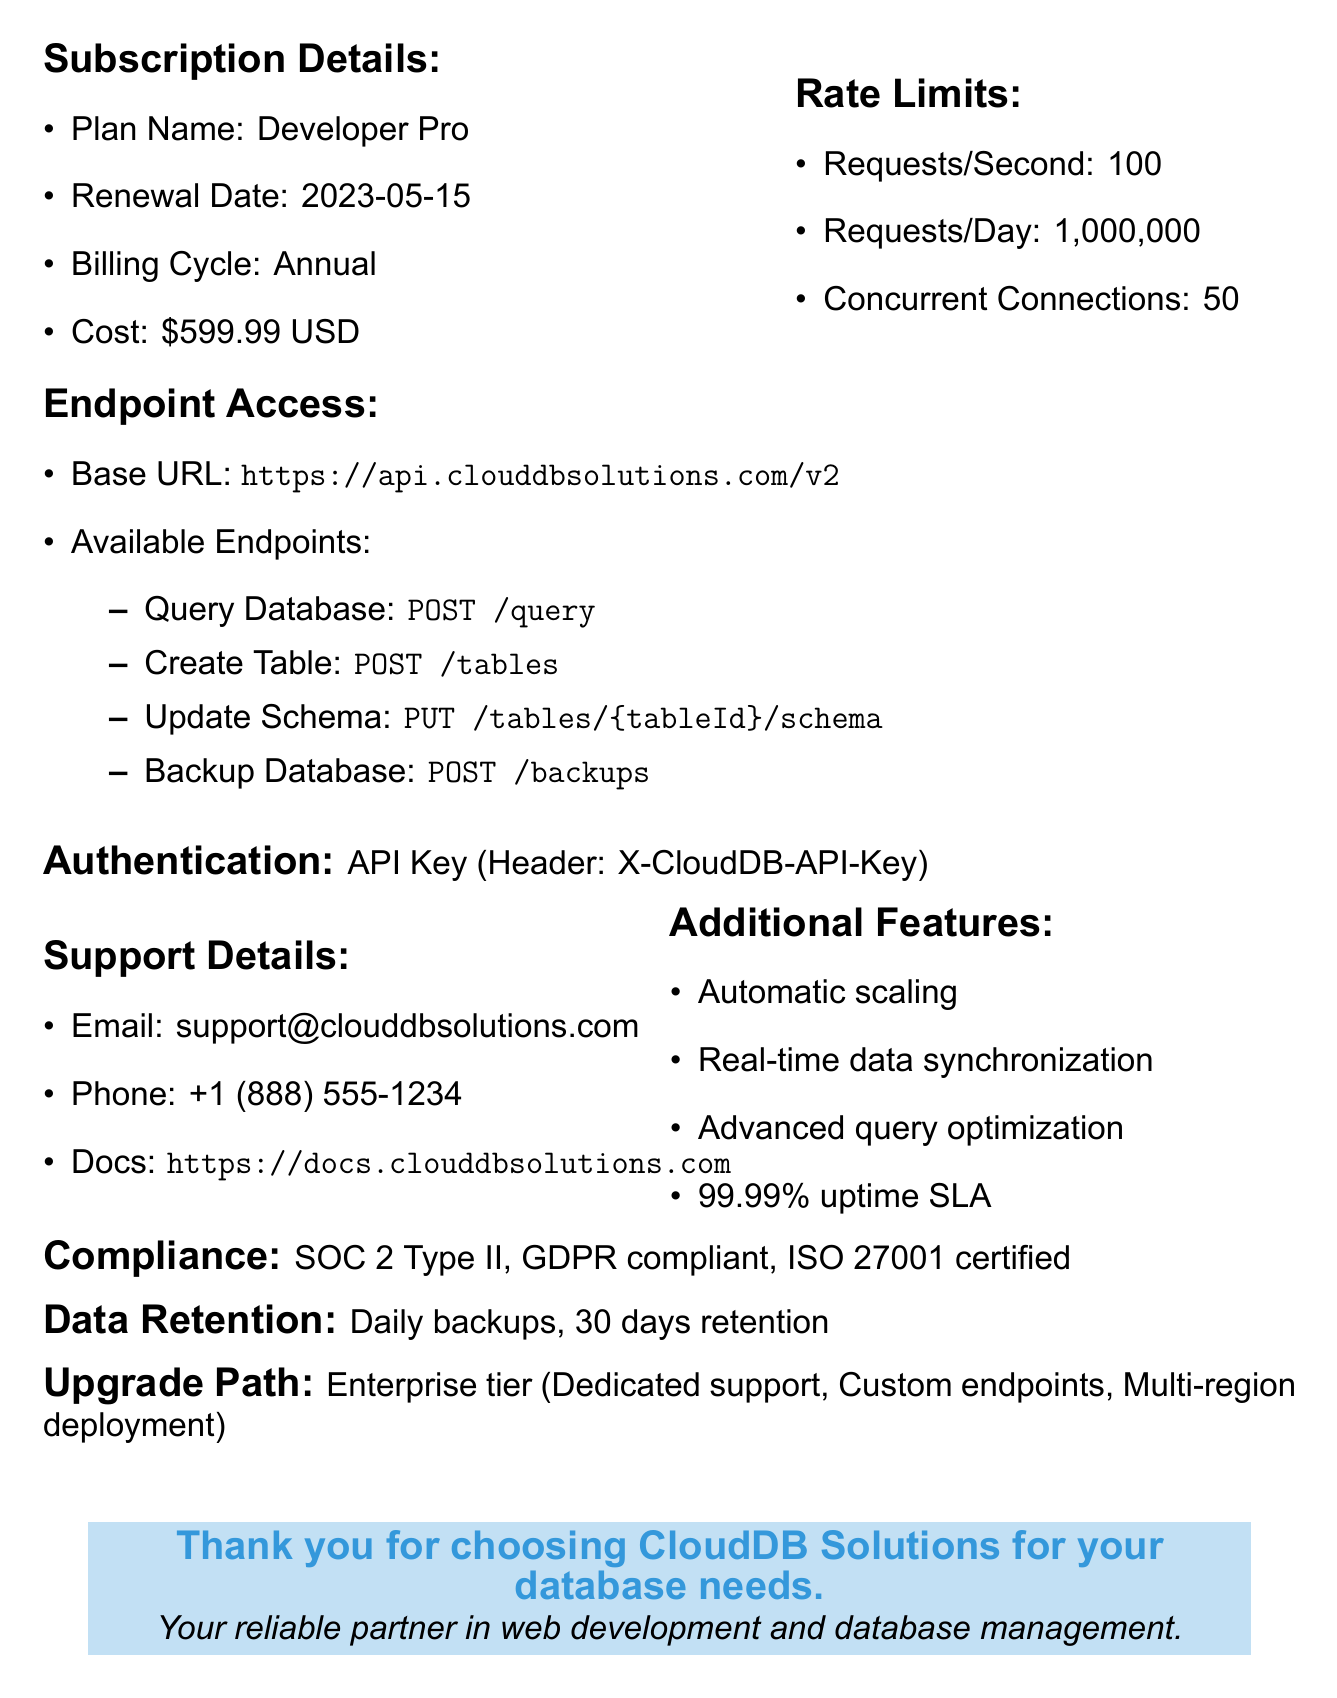What is the name of the subscription plan? The subscription plan name is provided under subscription details.
Answer: Developer Pro When is the renewal date of the subscription? The renewal date is specified in the subscription details section.
Answer: 2023-05-15 What is the cost of the subscription? The cost is mentioned in the subscription details along with its currency.
Answer: 599.99 USD How many requests can be made per day? The requests per day limit is specified in the rate limits section.
Answer: 1,000,000 What type of authentication is required? The type of authentication is mentioned in the authentication section of the document.
Answer: API Key Which endpoint is used to query the database? The endpoint for querying the database is listed in the endpoint access section.
Answer: POST /query What is the backup frequency mentioned in the data retention policy? The backup frequency is specified in the data retention policy.
Answer: Daily What is the next tier of subscription available? The next tier is listed in the upgrade path section of the document.
Answer: Enterprise What is the email address for support? The support email address is provided in the support details section.
Answer: support@clouddbsolutions.com 